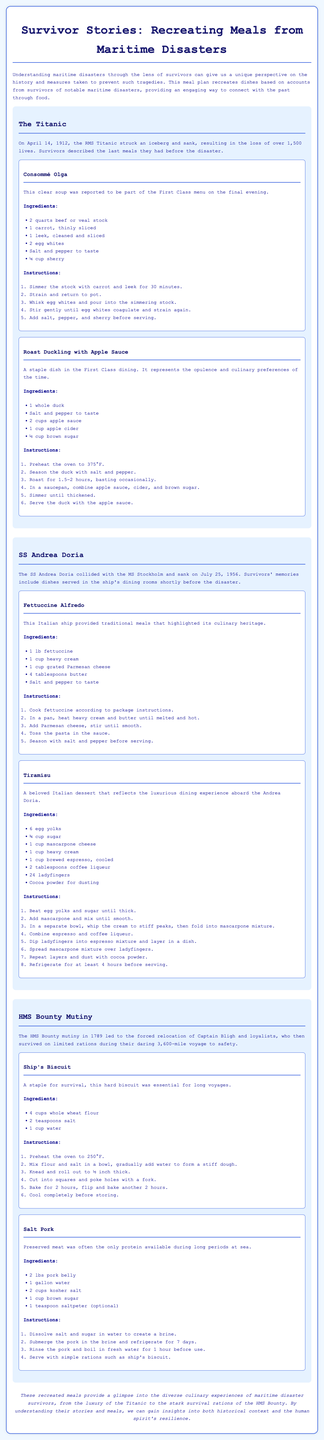What was the date of the Titanic disaster? The Titanic disaster occurred on April 14, 1912.
Answer: April 14, 1912 What dish was served as part of the Titanic's First Class menu? Consommé Olga was reported to be part of the First Class menu on the final evening of the Titanic.
Answer: Consommé Olga How many ladyfingers are used in the Tiramisu recipe? The recipe for Tiramisu requires 24 ladyfingers.
Answer: 24 What type of meat is used in the Salt Pork recipe? The Salt Pork recipe uses pork belly as the meat.
Answer: Pork belly Which culinary tradition does Fettuccine Alfredo represent? Fettuccine Alfredo represents Italian culinary tradition.
Answer: Italian How long should the Ship's Biscuit bake? Ship's Biscuit needs to bake for a total of 4 hours.
Answer: 4 hours What common element is present in the meals from HMS Bounty? A common element in the meals from HMS Bounty is preserved food due to limited rations.
Answer: Preserved food What is the main ingredient in the recipe for Roast Duckling? The main ingredient in the recipe for Roast Duckling is a whole duck.
Answer: Whole duck What beverage is paired with the dish Roast Duckling? Apple cider is paired with the dish Roast Duckling in the recipe.
Answer: Apple cider 